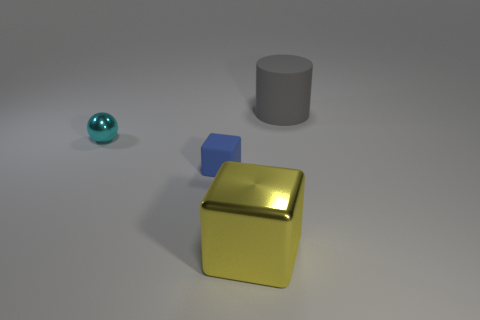There is a matte object that is left of the yellow cube; what size is it?
Give a very brief answer. Small. Is there another small object of the same color as the tiny matte thing?
Make the answer very short. No. Do the big rubber cylinder and the tiny shiny thing have the same color?
Your answer should be very brief. No. There is a big object behind the blue cube; how many small blue rubber cubes are on the right side of it?
Keep it short and to the point. 0. What number of cubes have the same material as the large yellow thing?
Ensure brevity in your answer.  0. Are there any matte blocks behind the tiny matte thing?
Your answer should be very brief. No. What color is the cube that is the same size as the gray matte object?
Keep it short and to the point. Yellow. What number of things are large yellow metal blocks in front of the rubber cylinder or gray things?
Provide a succinct answer. 2. There is a thing that is both on the left side of the big block and on the right side of the ball; what size is it?
Give a very brief answer. Small. What number of other things are there of the same size as the matte cube?
Provide a short and direct response. 1. 